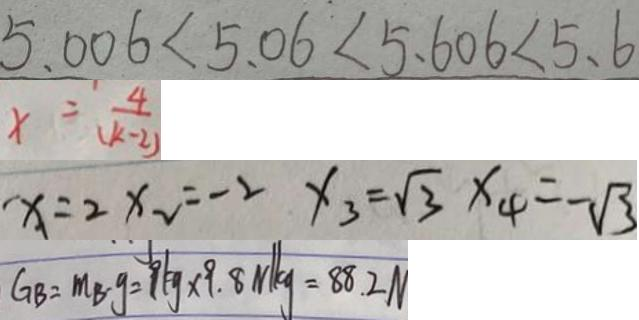<formula> <loc_0><loc_0><loc_500><loc_500>5 . 0 0 6 < 5 . 0 6 < 5 . 6 0 6 < 5 . 6 
 x = \frac { 4 } { ( k - 2 ) } 
 x = 2 x _ { 2 } = - 2 x _ { 3 } = \sqrt { 3 } x _ { 4 } = - \sqrt { 3 } 
 G B = m _ { B } \cdot g = 9 k g \times 9 . 8 N / k g = 8 8 . 2 N</formula> 